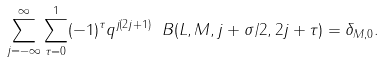Convert formula to latex. <formula><loc_0><loc_0><loc_500><loc_500>\sum _ { j = - \infty } ^ { \infty } \sum _ { \tau = 0 } ^ { 1 } ( - 1 ) ^ { \tau } q ^ { j ( 2 j + 1 ) } \ B ( L , M , j + \sigma / 2 , 2 j + \tau ) = \delta _ { M , 0 } .</formula> 